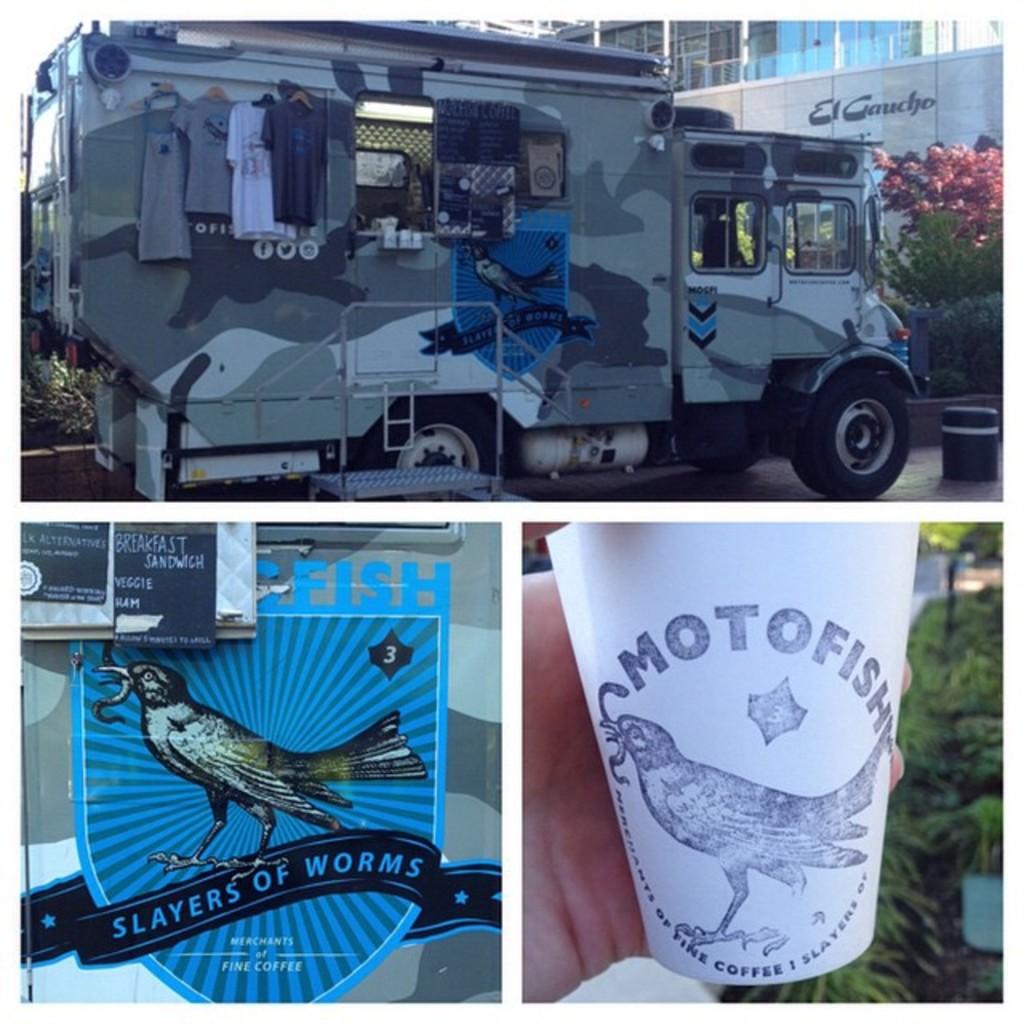What is the name of this drink company?
Keep it short and to the point. Motofish. Slayers of what?
Your response must be concise. Worms. 